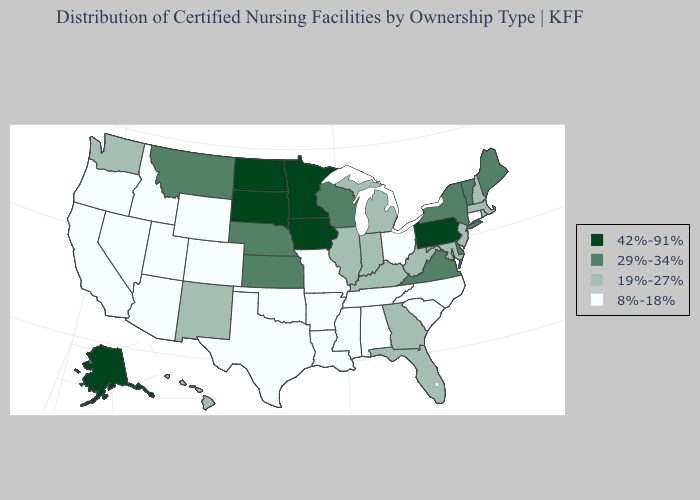Which states have the lowest value in the USA?
Be succinct. Alabama, Arizona, Arkansas, California, Colorado, Connecticut, Idaho, Louisiana, Mississippi, Missouri, Nevada, North Carolina, Ohio, Oklahoma, Oregon, South Carolina, Tennessee, Texas, Utah, Wyoming. Is the legend a continuous bar?
Be succinct. No. Does Utah have the same value as New Mexico?
Give a very brief answer. No. Name the states that have a value in the range 42%-91%?
Write a very short answer. Alaska, Iowa, Minnesota, North Dakota, Pennsylvania, South Dakota. What is the highest value in the South ?
Be succinct. 29%-34%. What is the value of Arkansas?
Give a very brief answer. 8%-18%. Name the states that have a value in the range 8%-18%?
Quick response, please. Alabama, Arizona, Arkansas, California, Colorado, Connecticut, Idaho, Louisiana, Mississippi, Missouri, Nevada, North Carolina, Ohio, Oklahoma, Oregon, South Carolina, Tennessee, Texas, Utah, Wyoming. Name the states that have a value in the range 42%-91%?
Keep it brief. Alaska, Iowa, Minnesota, North Dakota, Pennsylvania, South Dakota. Which states have the lowest value in the USA?
Be succinct. Alabama, Arizona, Arkansas, California, Colorado, Connecticut, Idaho, Louisiana, Mississippi, Missouri, Nevada, North Carolina, Ohio, Oklahoma, Oregon, South Carolina, Tennessee, Texas, Utah, Wyoming. Does the map have missing data?
Quick response, please. No. Does the map have missing data?
Give a very brief answer. No. Name the states that have a value in the range 29%-34%?
Be succinct. Delaware, Kansas, Maine, Montana, Nebraska, New York, Vermont, Virginia, Wisconsin. Name the states that have a value in the range 29%-34%?
Be succinct. Delaware, Kansas, Maine, Montana, Nebraska, New York, Vermont, Virginia, Wisconsin. 